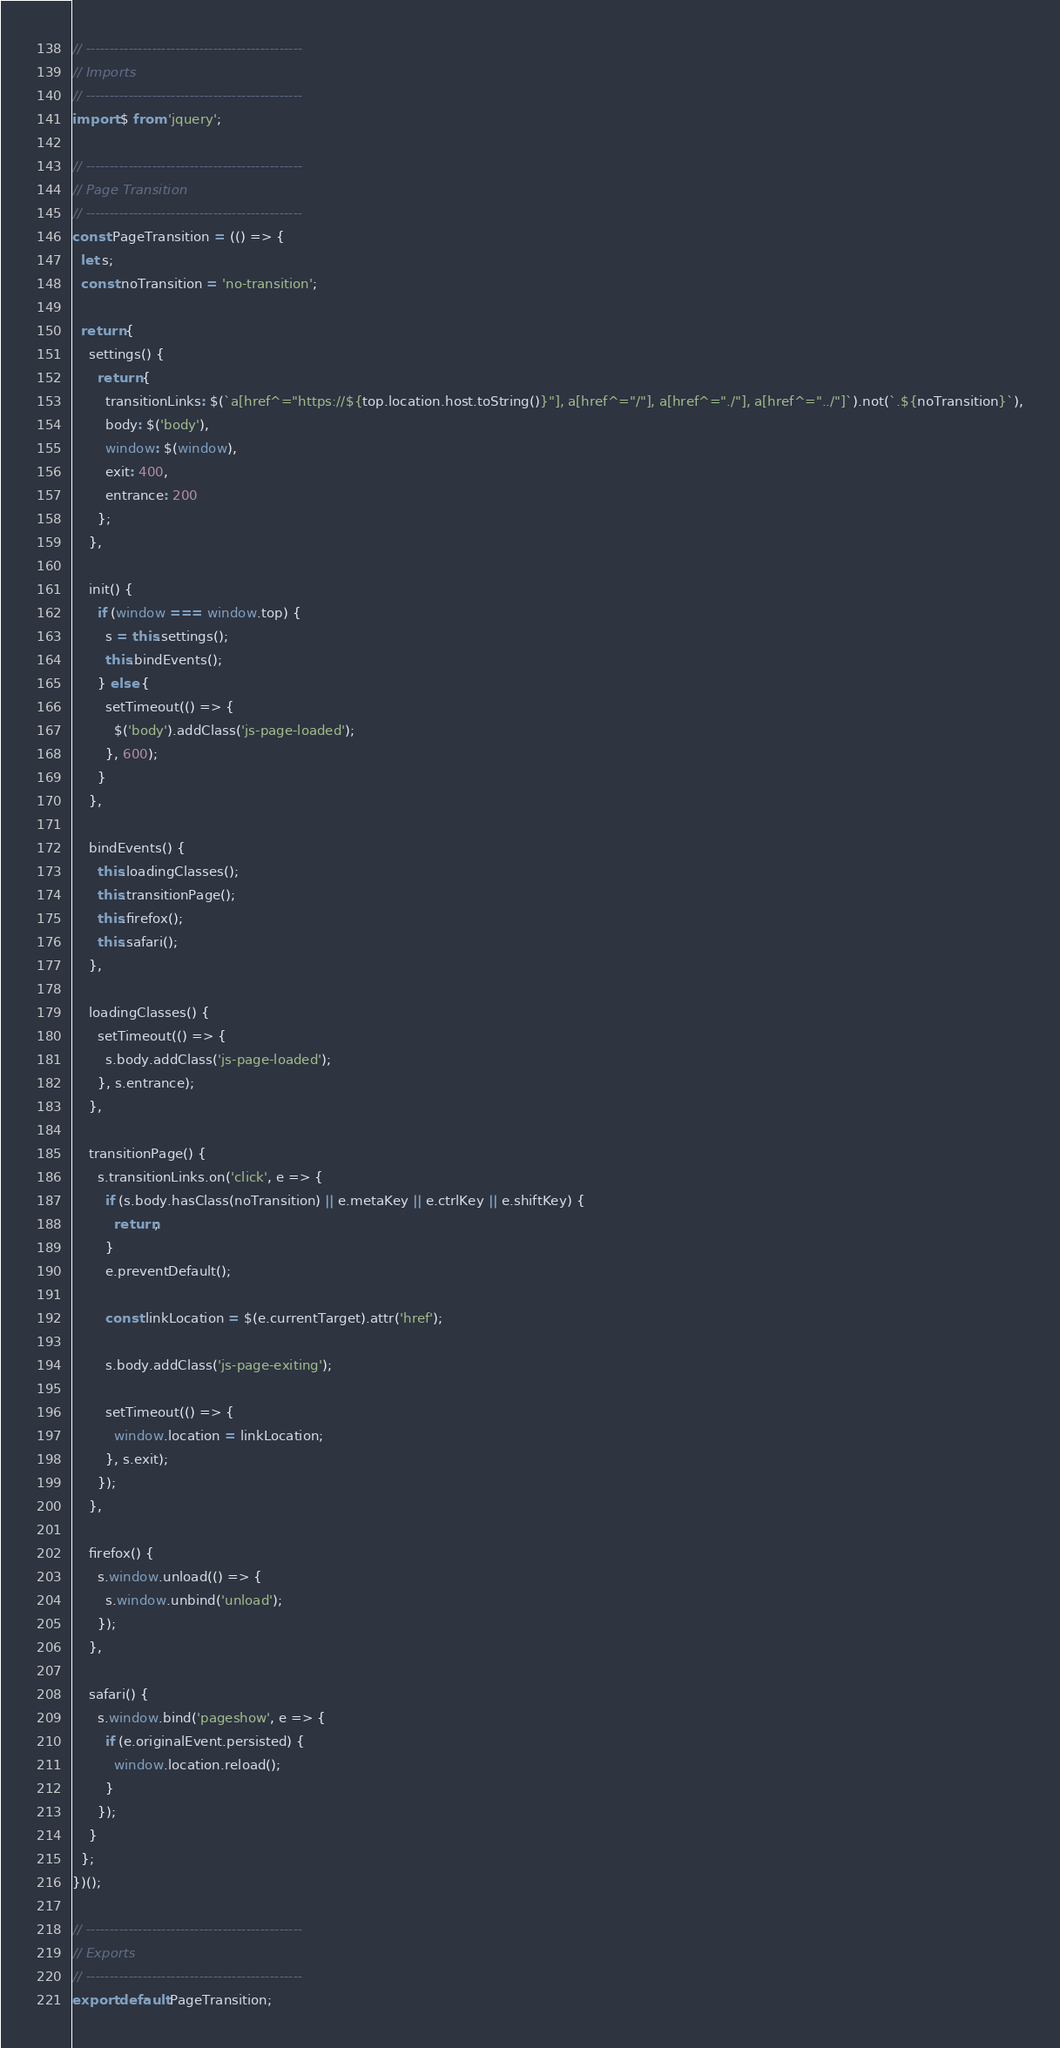Convert code to text. <code><loc_0><loc_0><loc_500><loc_500><_JavaScript_>// ----------------------------------------------
// Imports
// ----------------------------------------------
import $ from 'jquery';

// ----------------------------------------------
// Page Transition
// ----------------------------------------------
const PageTransition = (() => {
  let s;
  const noTransition = 'no-transition';

  return {
    settings() {
      return {
        transitionLinks: $(`a[href^="https://${top.location.host.toString()}"], a[href^="/"], a[href^="./"], a[href^="../"]`).not(`.${noTransition}`),
        body: $('body'),
        window: $(window),
        exit: 400,
        entrance: 200
      };
    },

    init() {
      if (window === window.top) {
        s = this.settings();
        this.bindEvents();
      } else {
        setTimeout(() => {
          $('body').addClass('js-page-loaded');
        }, 600);
      }
    },

    bindEvents() {
      this.loadingClasses();
      this.transitionPage();
      this.firefox();
      this.safari();
    },

    loadingClasses() {
      setTimeout(() => {
        s.body.addClass('js-page-loaded');
      }, s.entrance);
    },

    transitionPage() {
      s.transitionLinks.on('click', e => {
        if (s.body.hasClass(noTransition) || e.metaKey || e.ctrlKey || e.shiftKey) {
          return;
        }
        e.preventDefault();

        const linkLocation = $(e.currentTarget).attr('href');

        s.body.addClass('js-page-exiting');

        setTimeout(() => {
          window.location = linkLocation;
        }, s.exit);
      });
    },

    firefox() {
      s.window.unload(() => {
        s.window.unbind('unload');
      });
    },

    safari() {
      s.window.bind('pageshow', e => {
        if (e.originalEvent.persisted) {
          window.location.reload();
        }
      });
    }
  };
})();

// ----------------------------------------------
// Exports
// ----------------------------------------------
export default PageTransition;
</code> 